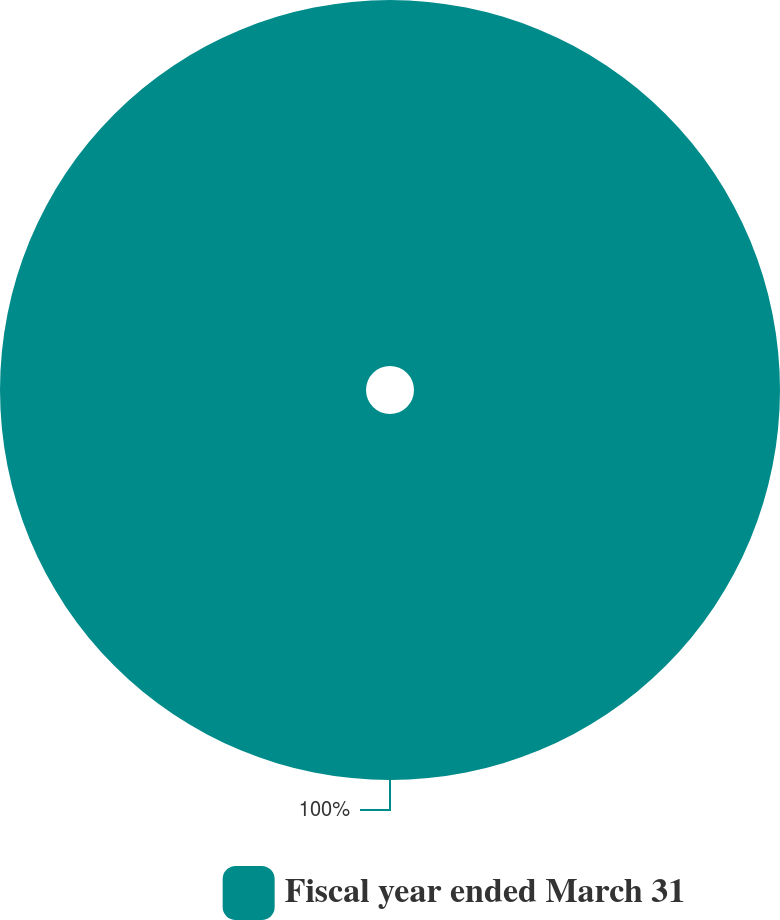Convert chart. <chart><loc_0><loc_0><loc_500><loc_500><pie_chart><fcel>Fiscal year ended March 31<nl><fcel>100.0%<nl></chart> 